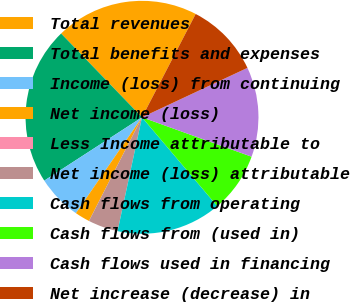Convert chart. <chart><loc_0><loc_0><loc_500><loc_500><pie_chart><fcel>Total revenues<fcel>Total benefits and expenses<fcel>Income (loss) from continuing<fcel>Net income (loss)<fcel>Less Income attributable to<fcel>Net income (loss) attributable<fcel>Cash flows from operating<fcel>Cash flows from (used in)<fcel>Cash flows used in financing<fcel>Net increase (decrease) in<nl><fcel>19.85%<fcel>21.93%<fcel>6.24%<fcel>2.08%<fcel>0.0%<fcel>4.16%<fcel>14.55%<fcel>8.32%<fcel>12.47%<fcel>10.4%<nl></chart> 